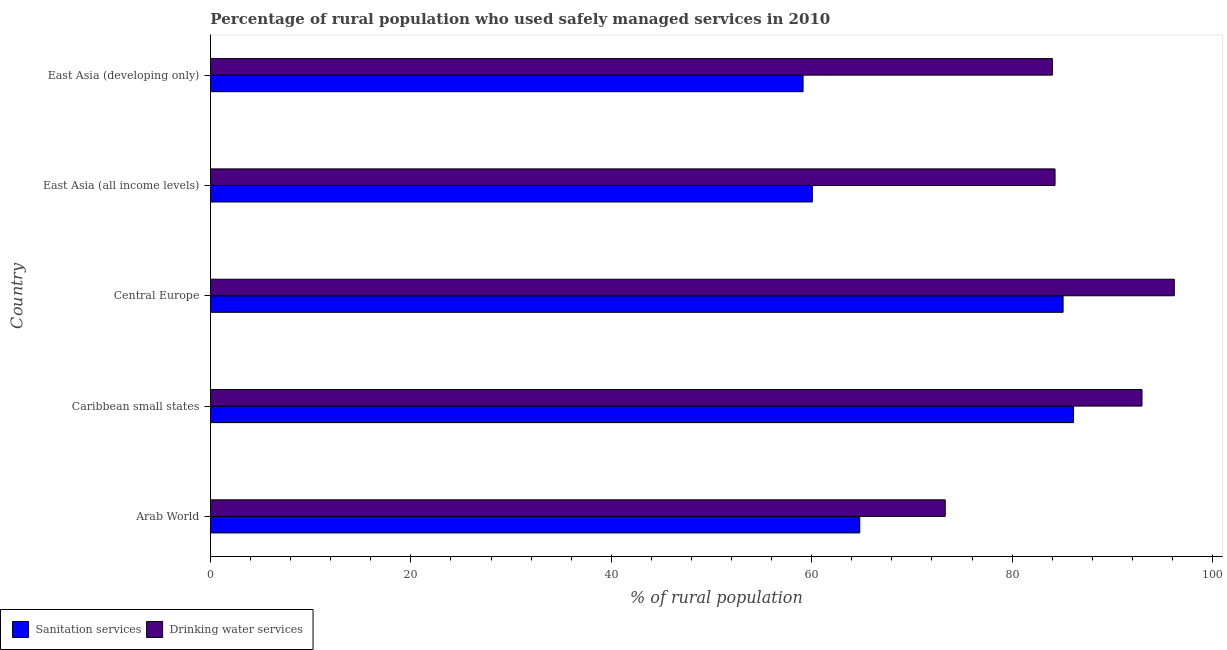How many groups of bars are there?
Your answer should be compact. 5. Are the number of bars on each tick of the Y-axis equal?
Provide a succinct answer. Yes. What is the label of the 5th group of bars from the top?
Offer a terse response. Arab World. In how many cases, is the number of bars for a given country not equal to the number of legend labels?
Your answer should be very brief. 0. What is the percentage of rural population who used sanitation services in East Asia (all income levels)?
Your response must be concise. 60.07. Across all countries, what is the maximum percentage of rural population who used drinking water services?
Keep it short and to the point. 96.19. Across all countries, what is the minimum percentage of rural population who used drinking water services?
Make the answer very short. 73.33. In which country was the percentage of rural population who used sanitation services maximum?
Provide a succinct answer. Caribbean small states. In which country was the percentage of rural population who used drinking water services minimum?
Offer a terse response. Arab World. What is the total percentage of rural population who used drinking water services in the graph?
Offer a terse response. 430.8. What is the difference between the percentage of rural population who used sanitation services in Caribbean small states and that in East Asia (all income levels)?
Give a very brief answer. 26.07. What is the difference between the percentage of rural population who used sanitation services in Central Europe and the percentage of rural population who used drinking water services in Caribbean small states?
Offer a very short reply. -7.88. What is the average percentage of rural population who used sanitation services per country?
Provide a short and direct response. 71.05. What is the difference between the percentage of rural population who used drinking water services and percentage of rural population who used sanitation services in Arab World?
Provide a succinct answer. 8.53. What is the ratio of the percentage of rural population who used drinking water services in Arab World to that in East Asia (developing only)?
Offer a terse response. 0.87. What is the difference between the highest and the second highest percentage of rural population who used sanitation services?
Give a very brief answer. 1.04. What is the difference between the highest and the lowest percentage of rural population who used sanitation services?
Your answer should be compact. 26.99. Is the sum of the percentage of rural population who used sanitation services in Arab World and East Asia (all income levels) greater than the maximum percentage of rural population who used drinking water services across all countries?
Keep it short and to the point. Yes. What does the 1st bar from the top in Central Europe represents?
Make the answer very short. Drinking water services. What does the 2nd bar from the bottom in East Asia (all income levels) represents?
Provide a short and direct response. Drinking water services. How many bars are there?
Keep it short and to the point. 10. Does the graph contain any zero values?
Keep it short and to the point. No. Does the graph contain grids?
Provide a short and direct response. No. Where does the legend appear in the graph?
Your answer should be compact. Bottom left. How many legend labels are there?
Your answer should be compact. 2. What is the title of the graph?
Your answer should be compact. Percentage of rural population who used safely managed services in 2010. What is the label or title of the X-axis?
Give a very brief answer. % of rural population. What is the label or title of the Y-axis?
Give a very brief answer. Country. What is the % of rural population of Sanitation services in Arab World?
Provide a succinct answer. 64.8. What is the % of rural population of Drinking water services in Arab World?
Provide a short and direct response. 73.33. What is the % of rural population of Sanitation services in Caribbean small states?
Your answer should be very brief. 86.13. What is the % of rural population of Drinking water services in Caribbean small states?
Your response must be concise. 92.97. What is the % of rural population of Sanitation services in Central Europe?
Make the answer very short. 85.09. What is the % of rural population in Drinking water services in Central Europe?
Your answer should be very brief. 96.19. What is the % of rural population in Sanitation services in East Asia (all income levels)?
Provide a succinct answer. 60.07. What is the % of rural population in Drinking water services in East Asia (all income levels)?
Give a very brief answer. 84.29. What is the % of rural population of Sanitation services in East Asia (developing only)?
Your answer should be very brief. 59.14. What is the % of rural population of Drinking water services in East Asia (developing only)?
Your answer should be compact. 84.02. Across all countries, what is the maximum % of rural population in Sanitation services?
Ensure brevity in your answer.  86.13. Across all countries, what is the maximum % of rural population of Drinking water services?
Make the answer very short. 96.19. Across all countries, what is the minimum % of rural population of Sanitation services?
Provide a succinct answer. 59.14. Across all countries, what is the minimum % of rural population in Drinking water services?
Provide a short and direct response. 73.33. What is the total % of rural population of Sanitation services in the graph?
Your answer should be compact. 355.23. What is the total % of rural population of Drinking water services in the graph?
Keep it short and to the point. 430.8. What is the difference between the % of rural population in Sanitation services in Arab World and that in Caribbean small states?
Give a very brief answer. -21.34. What is the difference between the % of rural population in Drinking water services in Arab World and that in Caribbean small states?
Give a very brief answer. -19.64. What is the difference between the % of rural population in Sanitation services in Arab World and that in Central Europe?
Provide a short and direct response. -20.29. What is the difference between the % of rural population in Drinking water services in Arab World and that in Central Europe?
Give a very brief answer. -22.86. What is the difference between the % of rural population of Sanitation services in Arab World and that in East Asia (all income levels)?
Keep it short and to the point. 4.73. What is the difference between the % of rural population of Drinking water services in Arab World and that in East Asia (all income levels)?
Offer a very short reply. -10.96. What is the difference between the % of rural population of Sanitation services in Arab World and that in East Asia (developing only)?
Ensure brevity in your answer.  5.66. What is the difference between the % of rural population in Drinking water services in Arab World and that in East Asia (developing only)?
Provide a succinct answer. -10.69. What is the difference between the % of rural population in Sanitation services in Caribbean small states and that in Central Europe?
Provide a short and direct response. 1.04. What is the difference between the % of rural population in Drinking water services in Caribbean small states and that in Central Europe?
Give a very brief answer. -3.22. What is the difference between the % of rural population in Sanitation services in Caribbean small states and that in East Asia (all income levels)?
Offer a very short reply. 26.07. What is the difference between the % of rural population in Drinking water services in Caribbean small states and that in East Asia (all income levels)?
Provide a short and direct response. 8.68. What is the difference between the % of rural population of Sanitation services in Caribbean small states and that in East Asia (developing only)?
Make the answer very short. 26.99. What is the difference between the % of rural population in Drinking water services in Caribbean small states and that in East Asia (developing only)?
Keep it short and to the point. 8.94. What is the difference between the % of rural population of Sanitation services in Central Europe and that in East Asia (all income levels)?
Provide a succinct answer. 25.02. What is the difference between the % of rural population in Drinking water services in Central Europe and that in East Asia (all income levels)?
Give a very brief answer. 11.9. What is the difference between the % of rural population of Sanitation services in Central Europe and that in East Asia (developing only)?
Give a very brief answer. 25.95. What is the difference between the % of rural population of Drinking water services in Central Europe and that in East Asia (developing only)?
Ensure brevity in your answer.  12.17. What is the difference between the % of rural population in Sanitation services in East Asia (all income levels) and that in East Asia (developing only)?
Your answer should be very brief. 0.92. What is the difference between the % of rural population of Drinking water services in East Asia (all income levels) and that in East Asia (developing only)?
Your answer should be very brief. 0.27. What is the difference between the % of rural population in Sanitation services in Arab World and the % of rural population in Drinking water services in Caribbean small states?
Your response must be concise. -28.17. What is the difference between the % of rural population of Sanitation services in Arab World and the % of rural population of Drinking water services in Central Europe?
Offer a terse response. -31.39. What is the difference between the % of rural population of Sanitation services in Arab World and the % of rural population of Drinking water services in East Asia (all income levels)?
Make the answer very short. -19.49. What is the difference between the % of rural population of Sanitation services in Arab World and the % of rural population of Drinking water services in East Asia (developing only)?
Offer a very short reply. -19.22. What is the difference between the % of rural population of Sanitation services in Caribbean small states and the % of rural population of Drinking water services in Central Europe?
Offer a terse response. -10.06. What is the difference between the % of rural population of Sanitation services in Caribbean small states and the % of rural population of Drinking water services in East Asia (all income levels)?
Provide a short and direct response. 1.85. What is the difference between the % of rural population of Sanitation services in Caribbean small states and the % of rural population of Drinking water services in East Asia (developing only)?
Your answer should be compact. 2.11. What is the difference between the % of rural population of Sanitation services in Central Europe and the % of rural population of Drinking water services in East Asia (all income levels)?
Provide a succinct answer. 0.8. What is the difference between the % of rural population of Sanitation services in Central Europe and the % of rural population of Drinking water services in East Asia (developing only)?
Provide a succinct answer. 1.07. What is the difference between the % of rural population of Sanitation services in East Asia (all income levels) and the % of rural population of Drinking water services in East Asia (developing only)?
Provide a succinct answer. -23.96. What is the average % of rural population of Sanitation services per country?
Keep it short and to the point. 71.05. What is the average % of rural population of Drinking water services per country?
Offer a very short reply. 86.16. What is the difference between the % of rural population of Sanitation services and % of rural population of Drinking water services in Arab World?
Offer a terse response. -8.53. What is the difference between the % of rural population of Sanitation services and % of rural population of Drinking water services in Caribbean small states?
Make the answer very short. -6.83. What is the difference between the % of rural population of Sanitation services and % of rural population of Drinking water services in Central Europe?
Keep it short and to the point. -11.1. What is the difference between the % of rural population in Sanitation services and % of rural population in Drinking water services in East Asia (all income levels)?
Provide a succinct answer. -24.22. What is the difference between the % of rural population of Sanitation services and % of rural population of Drinking water services in East Asia (developing only)?
Ensure brevity in your answer.  -24.88. What is the ratio of the % of rural population of Sanitation services in Arab World to that in Caribbean small states?
Your answer should be very brief. 0.75. What is the ratio of the % of rural population of Drinking water services in Arab World to that in Caribbean small states?
Your answer should be compact. 0.79. What is the ratio of the % of rural population of Sanitation services in Arab World to that in Central Europe?
Provide a short and direct response. 0.76. What is the ratio of the % of rural population in Drinking water services in Arab World to that in Central Europe?
Your response must be concise. 0.76. What is the ratio of the % of rural population of Sanitation services in Arab World to that in East Asia (all income levels)?
Give a very brief answer. 1.08. What is the ratio of the % of rural population in Drinking water services in Arab World to that in East Asia (all income levels)?
Your answer should be very brief. 0.87. What is the ratio of the % of rural population in Sanitation services in Arab World to that in East Asia (developing only)?
Provide a short and direct response. 1.1. What is the ratio of the % of rural population in Drinking water services in Arab World to that in East Asia (developing only)?
Provide a succinct answer. 0.87. What is the ratio of the % of rural population in Sanitation services in Caribbean small states to that in Central Europe?
Offer a very short reply. 1.01. What is the ratio of the % of rural population of Drinking water services in Caribbean small states to that in Central Europe?
Your response must be concise. 0.97. What is the ratio of the % of rural population of Sanitation services in Caribbean small states to that in East Asia (all income levels)?
Your answer should be very brief. 1.43. What is the ratio of the % of rural population in Drinking water services in Caribbean small states to that in East Asia (all income levels)?
Your answer should be very brief. 1.1. What is the ratio of the % of rural population in Sanitation services in Caribbean small states to that in East Asia (developing only)?
Offer a terse response. 1.46. What is the ratio of the % of rural population in Drinking water services in Caribbean small states to that in East Asia (developing only)?
Keep it short and to the point. 1.11. What is the ratio of the % of rural population in Sanitation services in Central Europe to that in East Asia (all income levels)?
Your answer should be compact. 1.42. What is the ratio of the % of rural population in Drinking water services in Central Europe to that in East Asia (all income levels)?
Provide a short and direct response. 1.14. What is the ratio of the % of rural population in Sanitation services in Central Europe to that in East Asia (developing only)?
Keep it short and to the point. 1.44. What is the ratio of the % of rural population in Drinking water services in Central Europe to that in East Asia (developing only)?
Keep it short and to the point. 1.14. What is the ratio of the % of rural population of Sanitation services in East Asia (all income levels) to that in East Asia (developing only)?
Keep it short and to the point. 1.02. What is the difference between the highest and the second highest % of rural population in Sanitation services?
Your response must be concise. 1.04. What is the difference between the highest and the second highest % of rural population in Drinking water services?
Provide a short and direct response. 3.22. What is the difference between the highest and the lowest % of rural population in Sanitation services?
Keep it short and to the point. 26.99. What is the difference between the highest and the lowest % of rural population of Drinking water services?
Your answer should be very brief. 22.86. 